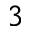<formula> <loc_0><loc_0><loc_500><loc_500>^ { 3 }</formula> 